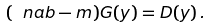<formula> <loc_0><loc_0><loc_500><loc_500>( \ n a b - m ) G ( y ) = D ( y ) \, .</formula> 